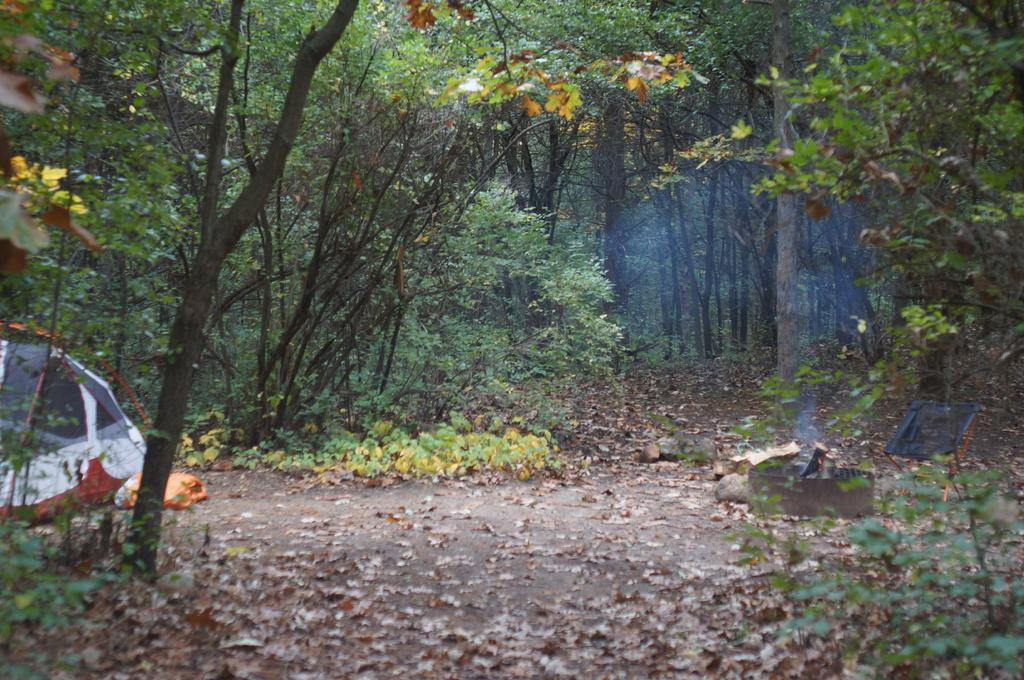What structure is located on the left side of the image? There is a tent on the left side of the image. What type of natural elements can be seen in the image? There are plants in the image. How are the plants distributed in the image? The plants are spread across the land. What is the condition of the leaves on the plants? Dry leaves are present on the plants. What type of brain can be seen on the plants in the image? There is no brain present on the plants in the image. What type of paper is visible in the image? There is no paper visible in the image. 